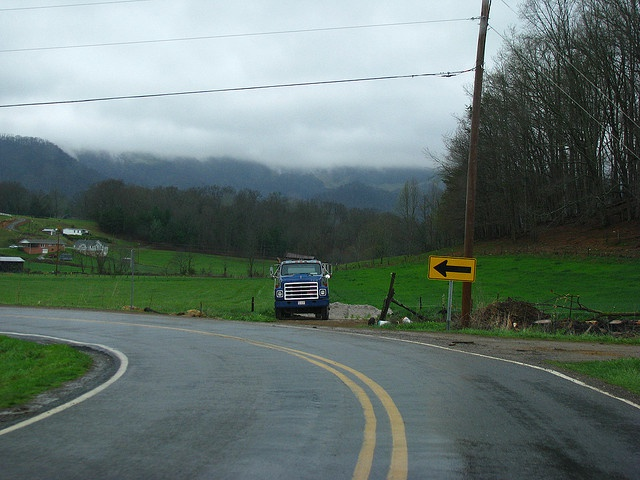Describe the objects in this image and their specific colors. I can see truck in lightgray, black, gray, blue, and navy tones and car in lightgray, black, darkgreen, and gray tones in this image. 